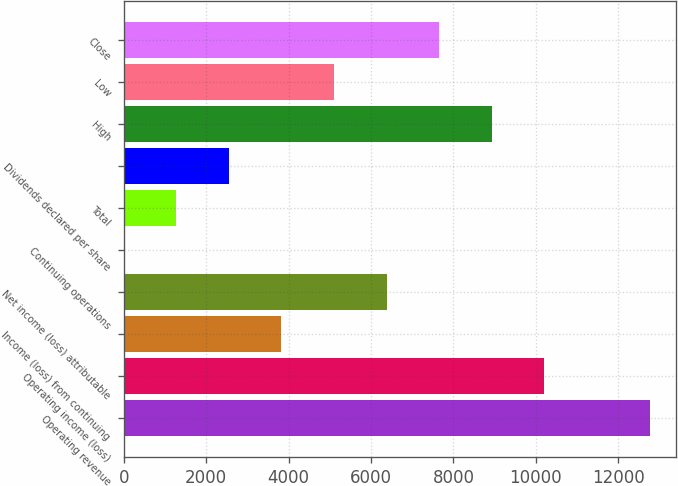Convert chart to OTSL. <chart><loc_0><loc_0><loc_500><loc_500><bar_chart><fcel>Operating revenue<fcel>Operating income (loss)<fcel>Income (loss) from continuing<fcel>Net income (loss) attributable<fcel>Continuing operations<fcel>Total<fcel>Dividends declared per share<fcel>High<fcel>Low<fcel>Close<nl><fcel>12760<fcel>10208<fcel>3828.07<fcel>6380.05<fcel>0.1<fcel>1276.09<fcel>2552.08<fcel>8932.03<fcel>5104.06<fcel>7656.04<nl></chart> 